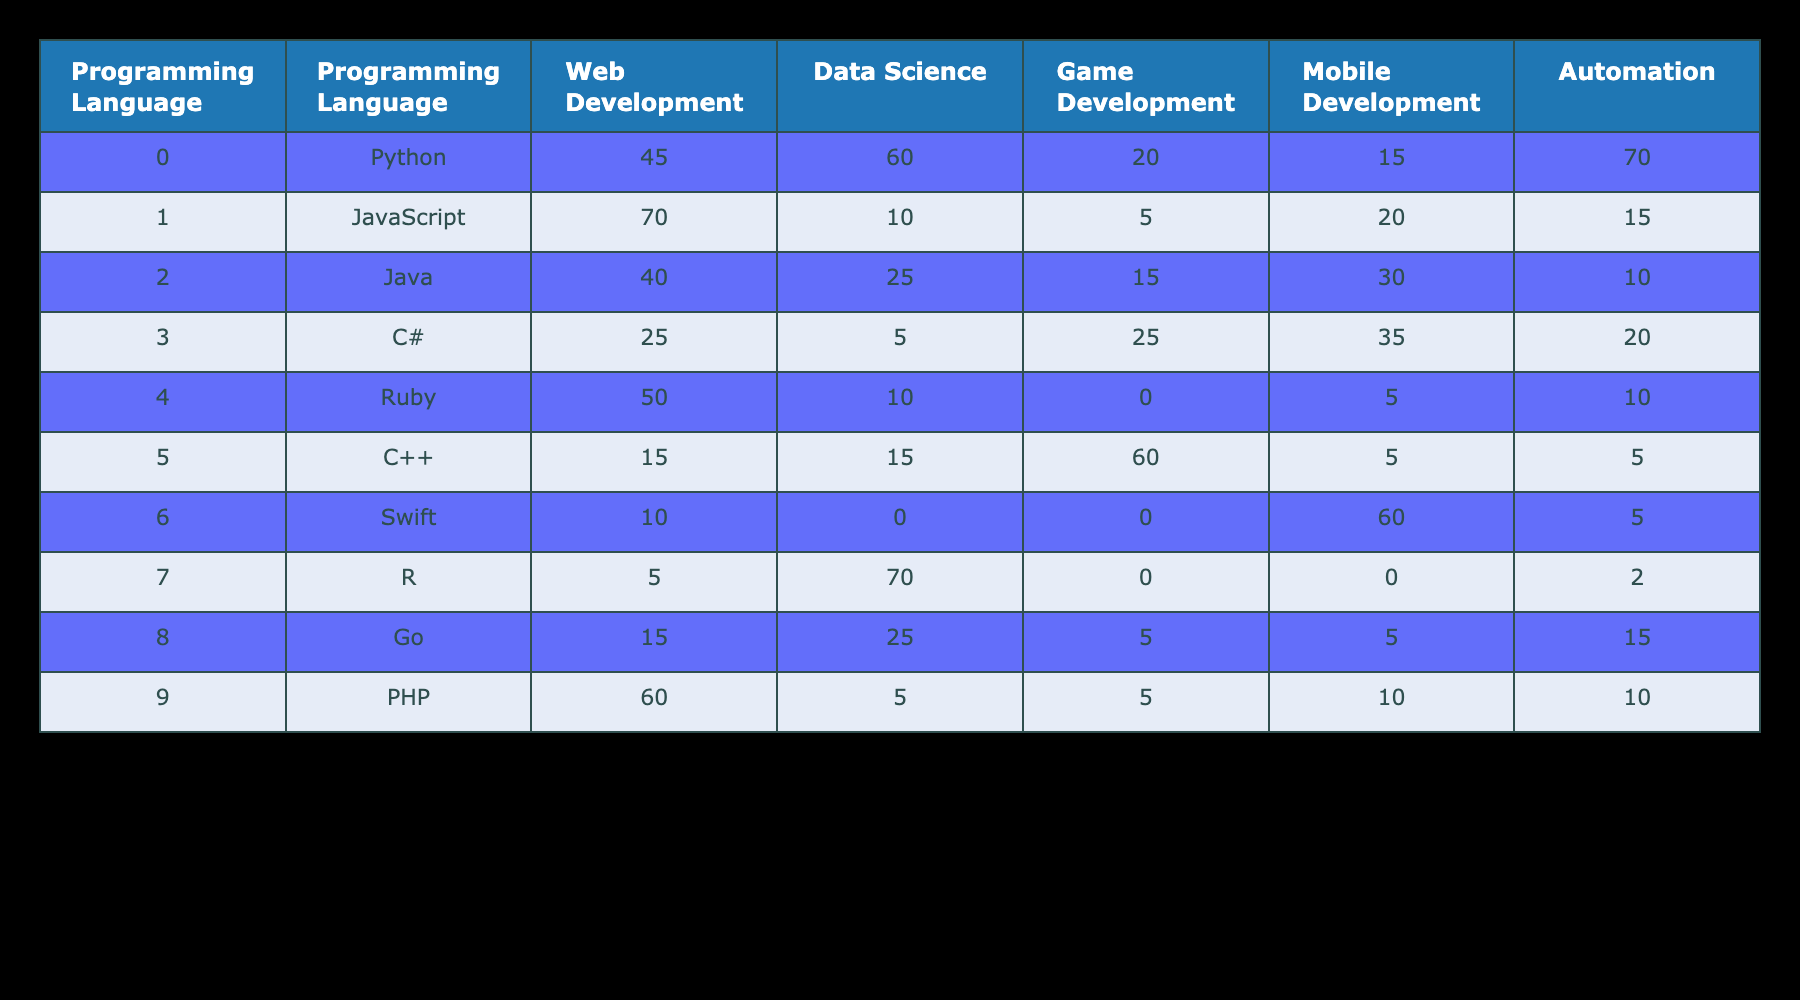What is the total number of projects undertaken in Data Science by all programming languages? To find the total number of projects in Data Science, we add the counts for each programming language in that column: 60 (Python) + 10 (JavaScript) + 25 (Java) + 5 (C#) + 10 (Ruby) + 15 (C++) + 0 (Swift) + 70 (R) + 25 (Go) + 5 (PHP) = 220.
Answer: 220 Which programming language has the highest number of projects in Game Development? The Game Development column is checked for the highest number. Python has 20, JavaScript has 5, Java has 15, C# has 25, Ruby has 0, C++ has 60, Swift has 0, R has 0, Go has 5, and PHP has 5. C++ has the highest value of 60.
Answer: C++ Does Python have more projects in Web Development compared to Java? Check the values for both programming languages in the Web Development column: Python has 45 and Java has 40. Since 45 is greater than 40, the statement is true.
Answer: Yes What is the average number of projects in Mobile Development for all programming languages? To find the average, sum the Mobile Development values: 15 (Python) + 20 (JavaScript) + 30 (Java) + 35 (C#) + 5 (Ruby) + 5 (C++) + 60 (Swift) + 0 (R) + 5 (Go) + 10 (PHP) = 150. There are 10 languages, so the average is 150/10 = 15.
Answer: 15 Which programming language has the least number of projects in Automation? The Automation column is compared across all languages. Python has 70, JavaScript has 15, Java has 10, C# has 20, Ruby has 10, C++ has 5, Swift has 5, R has 2, Go has 15, and PHP has 10. R has the least at 2.
Answer: R How many more projects does Python undertake in Data Science compared to Ruby? The values in the Data Science column are compared: Python has 60 and Ruby has 10. The difference is 60 - 10 = 50.
Answer: 50 Is there any programming language that has 0 projects in Mobile Development? In the Mobile Development column, we look for values equal to 0. Both Ruby and R have 0 projects in that category; thus, the statement is true.
Answer: Yes Which programming language is most versatile based on the number of different project types (columns) with non-zero values? Count the non-zero project types for each language. Python has 5 non-zero values, JavaScript has 4, Java has 4, C# has 4, Ruby has 2, C++ has 3, Swift has 2, R has 2, Go has 3, and PHP has 4. Python has the most, so it is the most versatile.
Answer: Python 